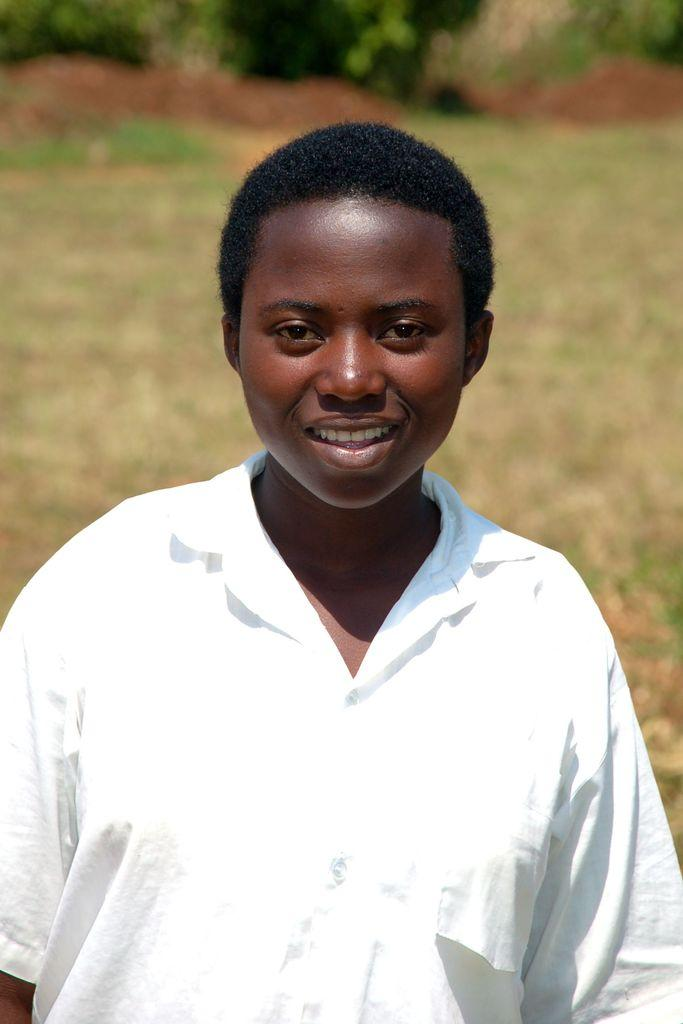What is the main subject in the foreground of the image? There is a person standing in the foreground of the image. What is the facial expression of the person in the image? The person has a smile on their face. What type of natural environment is visible in the background of the image? There is grass and trees in the background of the image. What type of songs can be heard playing in the background of the image? There is no audio or music present in the image, so it is not possible to determine what songs might be heard. 